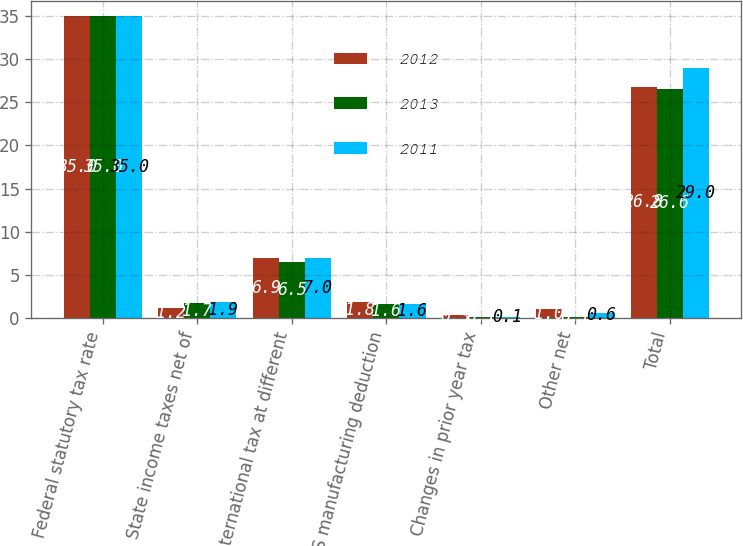Convert chart. <chart><loc_0><loc_0><loc_500><loc_500><stacked_bar_chart><ecel><fcel>Federal statutory tax rate<fcel>State income taxes net of<fcel>International tax at different<fcel>US manufacturing deduction<fcel>Changes in prior year tax<fcel>Other net<fcel>Total<nl><fcel>2012<fcel>35<fcel>1.2<fcel>6.9<fcel>1.8<fcel>0.3<fcel>1<fcel>26.8<nl><fcel>2013<fcel>35<fcel>1.7<fcel>6.5<fcel>1.6<fcel>0.1<fcel>0.1<fcel>26.6<nl><fcel>2011<fcel>35<fcel>1.9<fcel>7<fcel>1.6<fcel>0.1<fcel>0.6<fcel>29<nl></chart> 